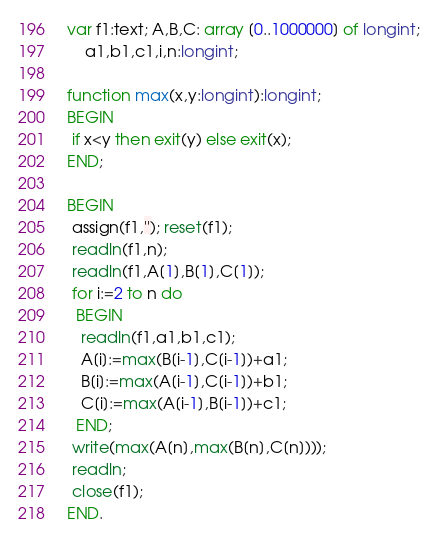Convert code to text. <code><loc_0><loc_0><loc_500><loc_500><_Pascal_> var f1:text; A,B,C: array [0..1000000] of longint;
     a1,b1,c1,i,n:longint;

 function max(x,y:longint):longint;
 BEGIN
  if x<y then exit(y) else exit(x);
 END;

 BEGIN
  assign(f1,''); reset(f1);
  readln(f1,n);
  readln(f1,A[1],B[1],C[1]);
  for i:=2 to n do
   BEGIN
    readln(f1,a1,b1,c1);
    A[i]:=max(B[i-1],C[i-1])+a1;
    B[i]:=max(A[i-1],C[i-1])+b1;
    C[i]:=max(A[i-1],B[i-1])+c1;
   END;
  write(max(A[n],max(B[n],C[n])));
  readln;
  close(f1);
 END.

</code> 